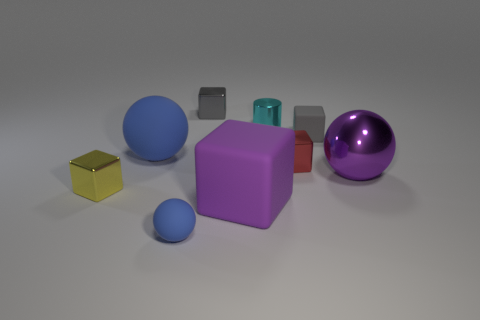Subtract all blue balls. How many were subtracted if there are1blue balls left? 1 Subtract all cyan blocks. Subtract all brown spheres. How many blocks are left? 5 Add 1 cyan shiny cylinders. How many objects exist? 10 Subtract all cylinders. How many objects are left? 8 Subtract 1 red blocks. How many objects are left? 8 Subtract all big brown spheres. Subtract all small blue objects. How many objects are left? 8 Add 7 yellow objects. How many yellow objects are left? 8 Add 8 big yellow matte cylinders. How many big yellow matte cylinders exist? 8 